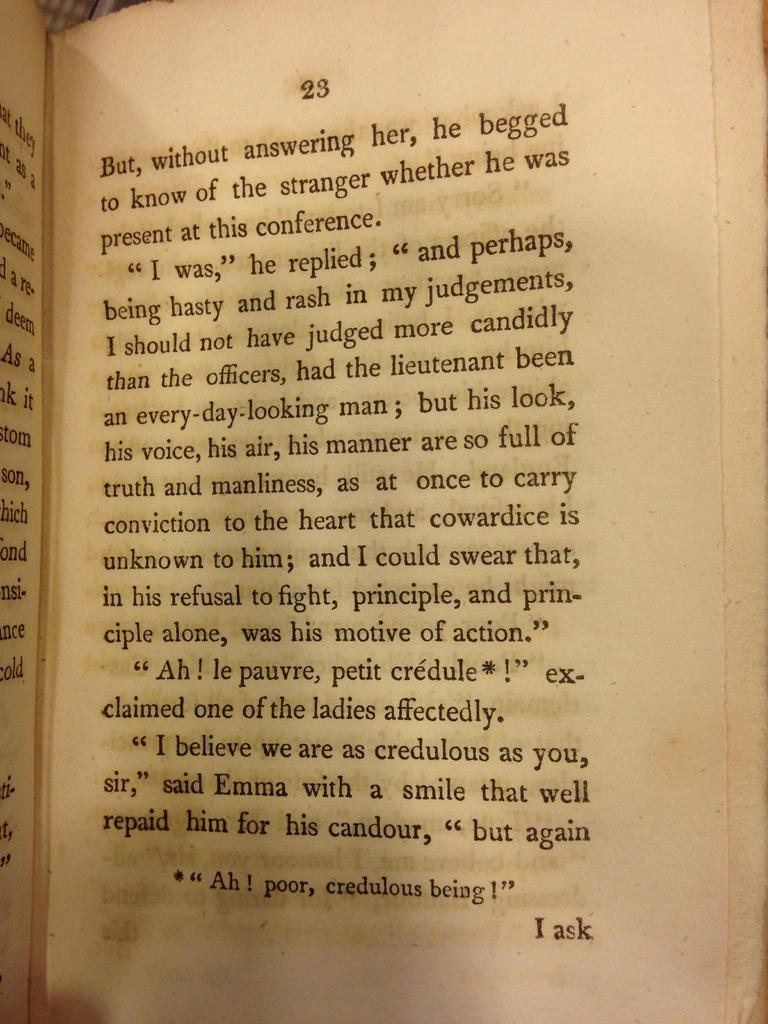<image>
Create a compact narrative representing the image presented. page 23 of a book that ends with 'i ask' 